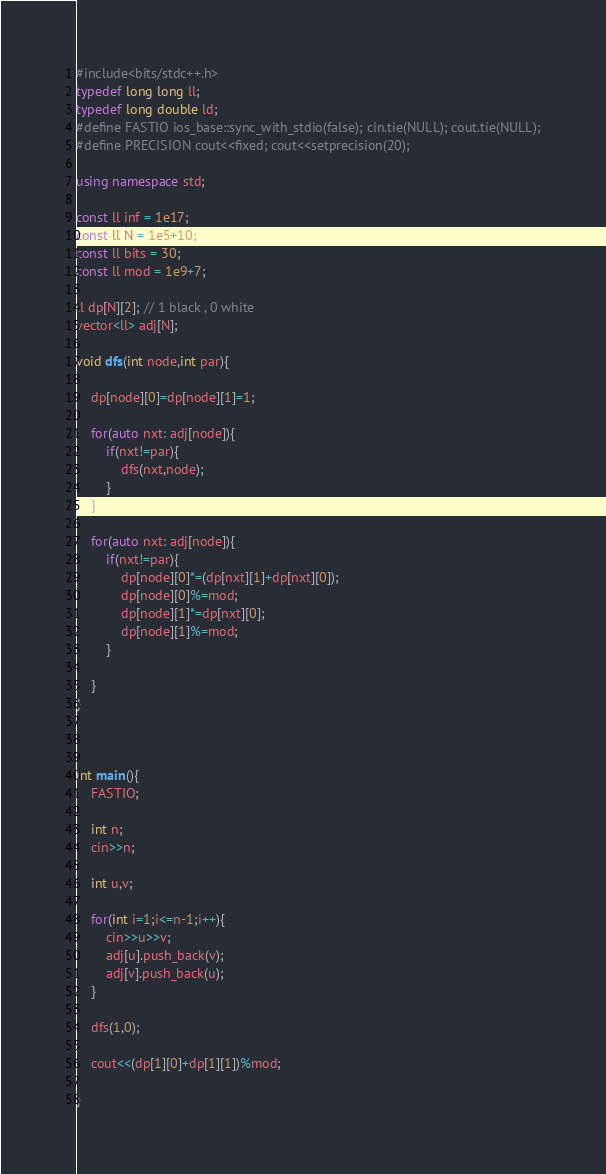Convert code to text. <code><loc_0><loc_0><loc_500><loc_500><_C++_>#include<bits/stdc++.h>
typedef long long ll;
typedef long double ld;
#define FASTIO ios_base::sync_with_stdio(false); cin.tie(NULL); cout.tie(NULL);
#define PRECISION cout<<fixed; cout<<setprecision(20);
  
using namespace std;
 
const ll inf = 1e17;
const ll N = 1e5+10;
const ll bits = 30;
const ll mod = 1e9+7;

ll dp[N][2]; // 1 black , 0 white
vector<ll> adj[N];

void dfs(int node,int par){

    dp[node][0]=dp[node][1]=1;

    for(auto nxt: adj[node]){
        if(nxt!=par){
            dfs(nxt,node);
        }
    }

    for(auto nxt: adj[node]){
        if(nxt!=par){
            dp[node][0]*=(dp[nxt][1]+dp[nxt][0]);
            dp[node][0]%=mod;
            dp[node][1]*=dp[nxt][0];
            dp[node][1]%=mod;
        }
        
    }
}



int main(){
    FASTIO;
    
    int n;
    cin>>n;

    int u,v;

    for(int i=1;i<=n-1;i++){
        cin>>u>>v;
        adj[u].push_back(v);
        adj[v].push_back(u);
    }

    dfs(1,0);

    cout<<(dp[1][0]+dp[1][1])%mod;

}</code> 